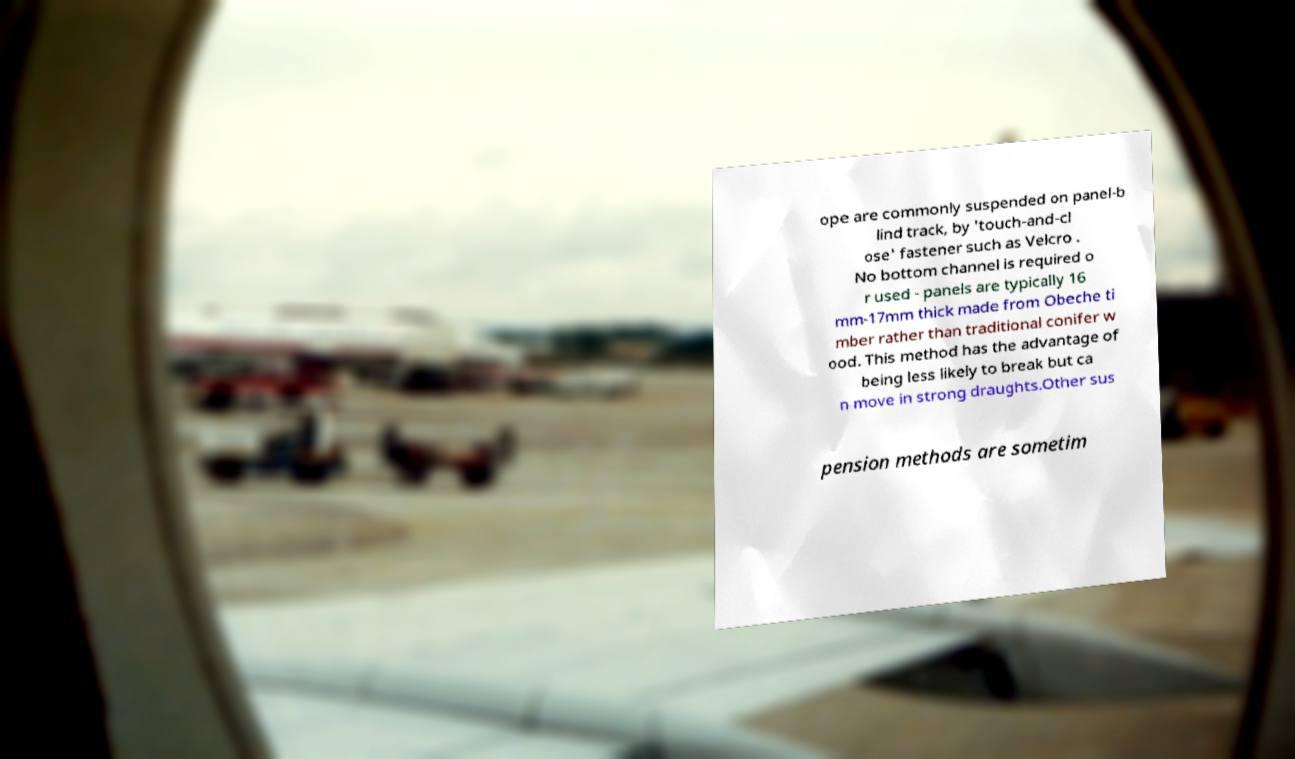Could you extract and type out the text from this image? ope are commonly suspended on panel-b lind track, by 'touch-and-cl ose' fastener such as Velcro . No bottom channel is required o r used - panels are typically 16 mm-17mm thick made from Obeche ti mber rather than traditional conifer w ood. This method has the advantage of being less likely to break but ca n move in strong draughts.Other sus pension methods are sometim 